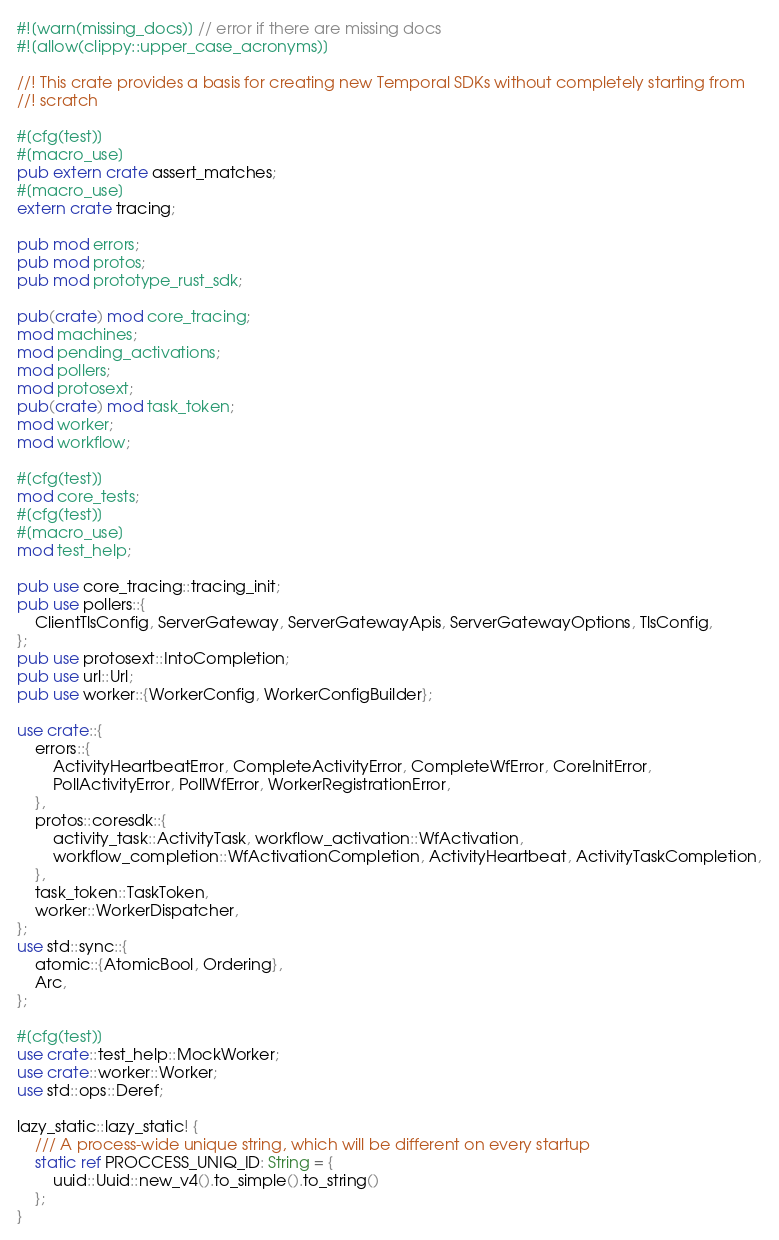<code> <loc_0><loc_0><loc_500><loc_500><_Rust_>#![warn(missing_docs)] // error if there are missing docs
#![allow(clippy::upper_case_acronyms)]

//! This crate provides a basis for creating new Temporal SDKs without completely starting from
//! scratch

#[cfg(test)]
#[macro_use]
pub extern crate assert_matches;
#[macro_use]
extern crate tracing;

pub mod errors;
pub mod protos;
pub mod prototype_rust_sdk;

pub(crate) mod core_tracing;
mod machines;
mod pending_activations;
mod pollers;
mod protosext;
pub(crate) mod task_token;
mod worker;
mod workflow;

#[cfg(test)]
mod core_tests;
#[cfg(test)]
#[macro_use]
mod test_help;

pub use core_tracing::tracing_init;
pub use pollers::{
    ClientTlsConfig, ServerGateway, ServerGatewayApis, ServerGatewayOptions, TlsConfig,
};
pub use protosext::IntoCompletion;
pub use url::Url;
pub use worker::{WorkerConfig, WorkerConfigBuilder};

use crate::{
    errors::{
        ActivityHeartbeatError, CompleteActivityError, CompleteWfError, CoreInitError,
        PollActivityError, PollWfError, WorkerRegistrationError,
    },
    protos::coresdk::{
        activity_task::ActivityTask, workflow_activation::WfActivation,
        workflow_completion::WfActivationCompletion, ActivityHeartbeat, ActivityTaskCompletion,
    },
    task_token::TaskToken,
    worker::WorkerDispatcher,
};
use std::sync::{
    atomic::{AtomicBool, Ordering},
    Arc,
};

#[cfg(test)]
use crate::test_help::MockWorker;
use crate::worker::Worker;
use std::ops::Deref;

lazy_static::lazy_static! {
    /// A process-wide unique string, which will be different on every startup
    static ref PROCCESS_UNIQ_ID: String = {
        uuid::Uuid::new_v4().to_simple().to_string()
    };
}
</code> 